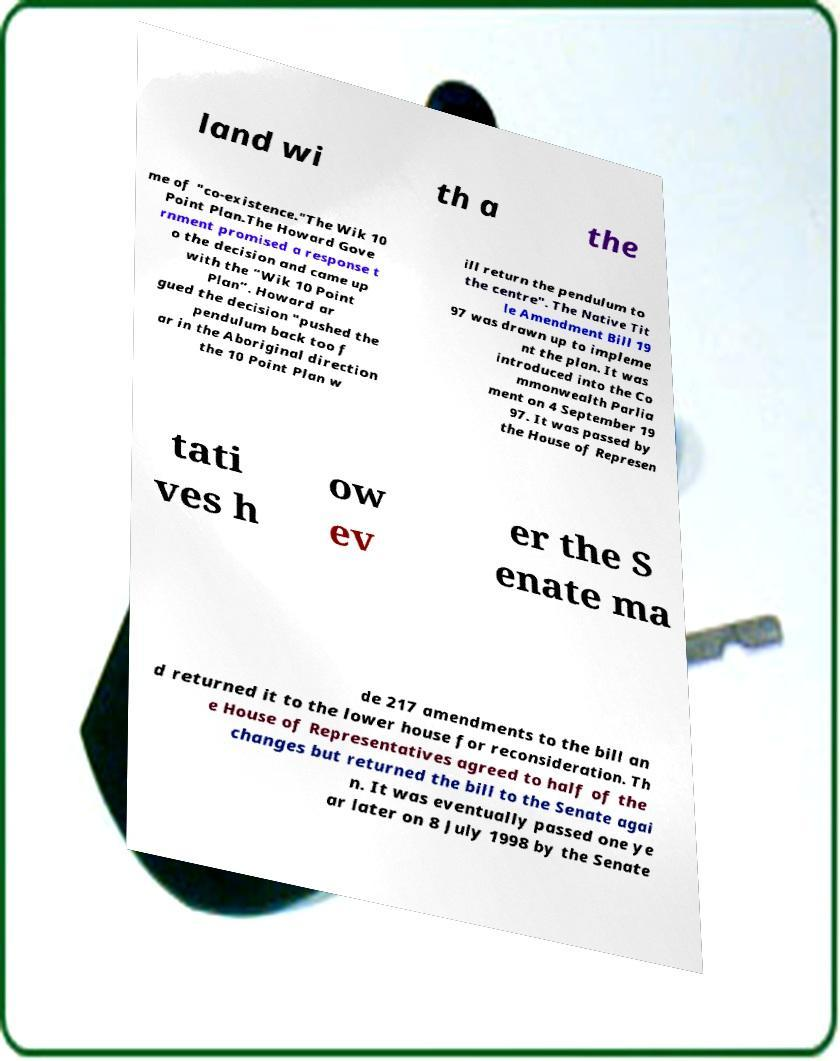Can you read and provide the text displayed in the image?This photo seems to have some interesting text. Can you extract and type it out for me? land wi th a the me of "co-existence."The Wik 10 Point Plan.The Howard Gove rnment promised a response t o the decision and came up with the “Wik 10 Point Plan”. Howard ar gued the decision "pushed the pendulum back too f ar in the Aboriginal direction the 10 Point Plan w ill return the pendulum to the centre". The Native Tit le Amendment Bill 19 97 was drawn up to impleme nt the plan. It was introduced into the Co mmonwealth Parlia ment on 4 September 19 97. It was passed by the House of Represen tati ves h ow ev er the S enate ma de 217 amendments to the bill an d returned it to the lower house for reconsideration. Th e House of Representatives agreed to half of the changes but returned the bill to the Senate agai n. It was eventually passed one ye ar later on 8 July 1998 by the Senate 